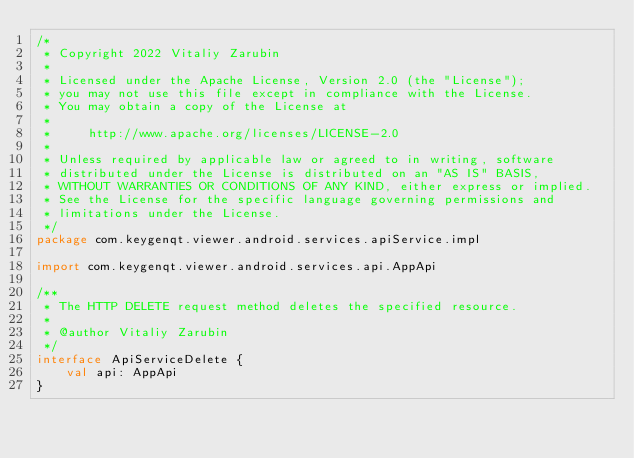<code> <loc_0><loc_0><loc_500><loc_500><_Kotlin_>/*
 * Copyright 2022 Vitaliy Zarubin
 *
 * Licensed under the Apache License, Version 2.0 (the "License");
 * you may not use this file except in compliance with the License.
 * You may obtain a copy of the License at
 *
 *     http://www.apache.org/licenses/LICENSE-2.0
 *
 * Unless required by applicable law or agreed to in writing, software
 * distributed under the License is distributed on an "AS IS" BASIS,
 * WITHOUT WARRANTIES OR CONDITIONS OF ANY KIND, either express or implied.
 * See the License for the specific language governing permissions and
 * limitations under the License.
 */
package com.keygenqt.viewer.android.services.apiService.impl

import com.keygenqt.viewer.android.services.api.AppApi

/**
 * The HTTP DELETE request method deletes the specified resource.
 *
 * @author Vitaliy Zarubin
 */
interface ApiServiceDelete {
    val api: AppApi
}
</code> 